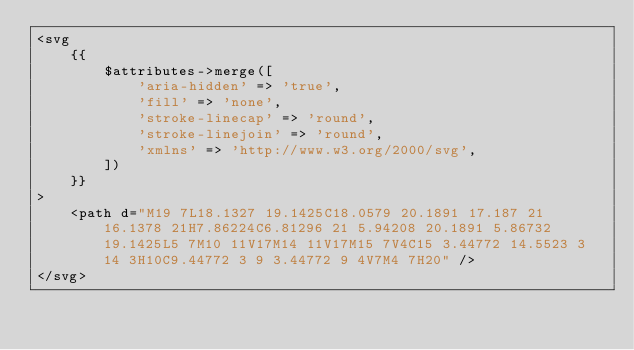<code> <loc_0><loc_0><loc_500><loc_500><_PHP_><svg
    {{
        $attributes->merge([
            'aria-hidden' => 'true',
            'fill' => 'none',
            'stroke-linecap' => 'round',
            'stroke-linejoin' => 'round',
            'xmlns' => 'http://www.w3.org/2000/svg',
        ])
    }}
>
    <path d="M19 7L18.1327 19.1425C18.0579 20.1891 17.187 21 16.1378 21H7.86224C6.81296 21 5.94208 20.1891 5.86732 19.1425L5 7M10 11V17M14 11V17M15 7V4C15 3.44772 14.5523 3 14 3H10C9.44772 3 9 3.44772 9 4V7M4 7H20" />
</svg>
</code> 